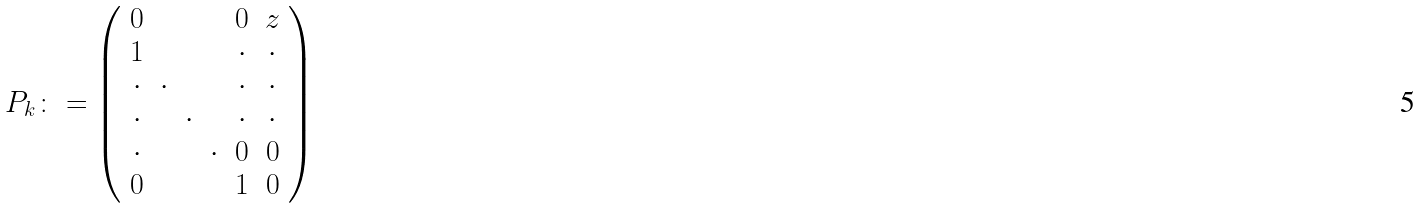<formula> <loc_0><loc_0><loc_500><loc_500>P _ { k } \colon = \left ( \begin{array} { c c c c c c } 0 & & & & 0 & z \\ 1 & & & & \cdot & \cdot \\ \cdot & \cdot & & & \cdot & \cdot \\ \cdot & & \cdot & & \cdot & \cdot \\ \cdot & & & \cdot & 0 & 0 \\ 0 & & & & 1 & 0 \end{array} \right )</formula> 